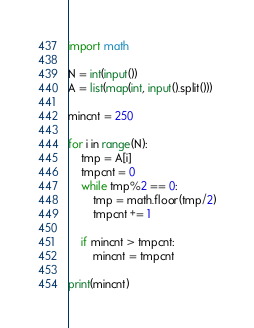Convert code to text. <code><loc_0><loc_0><loc_500><loc_500><_Python_>import math

N = int(input())
A = list(map(int, input().split()))

mincnt = 250

for i in range(N):
    tmp = A[i]
    tmpcnt = 0
    while tmp%2 == 0:
        tmp = math.floor(tmp/2)
        tmpcnt += 1

    if mincnt > tmpcnt:
        mincnt = tmpcnt

print(mincnt)
</code> 